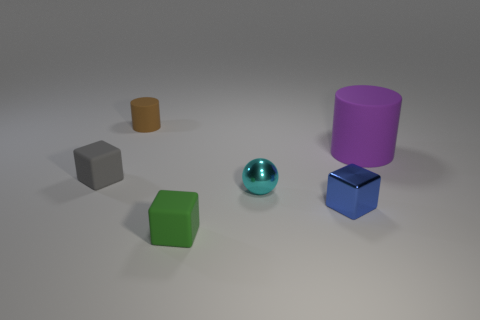Does the tiny rubber cylinder have the same color as the tiny metallic block?
Your response must be concise. No. There is a matte cylinder that is the same size as the gray matte thing; what is its color?
Make the answer very short. Brown. How many gray things are tiny metallic spheres or tiny rubber objects?
Give a very brief answer. 1. Are there more metallic cubes than yellow shiny cylinders?
Your answer should be compact. Yes. There is a matte thing that is in front of the tiny blue block; is its size the same as the rubber cylinder to the left of the blue object?
Provide a short and direct response. Yes. The tiny rubber block behind the matte cube that is in front of the small rubber block on the left side of the brown rubber object is what color?
Offer a terse response. Gray. Is there another rubber thing that has the same shape as the blue object?
Your answer should be very brief. Yes. Is the number of green objects that are to the right of the small cyan sphere greater than the number of green matte cylinders?
Your answer should be compact. No. How many shiny objects are small yellow balls or cubes?
Offer a very short reply. 1. How big is the matte object that is on the right side of the tiny brown cylinder and behind the tiny green matte object?
Make the answer very short. Large. 